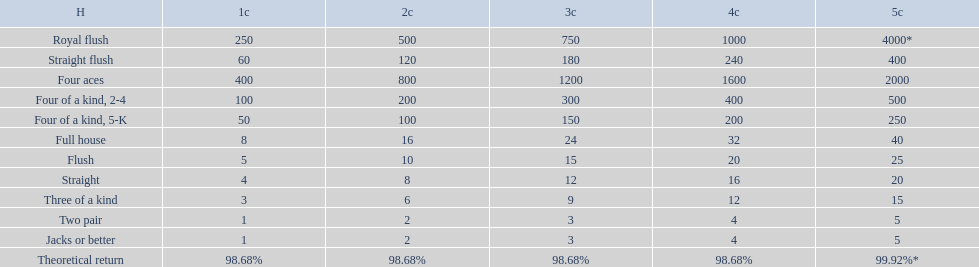What's the best type of four of a kind to win? Four of a kind, 2-4. 